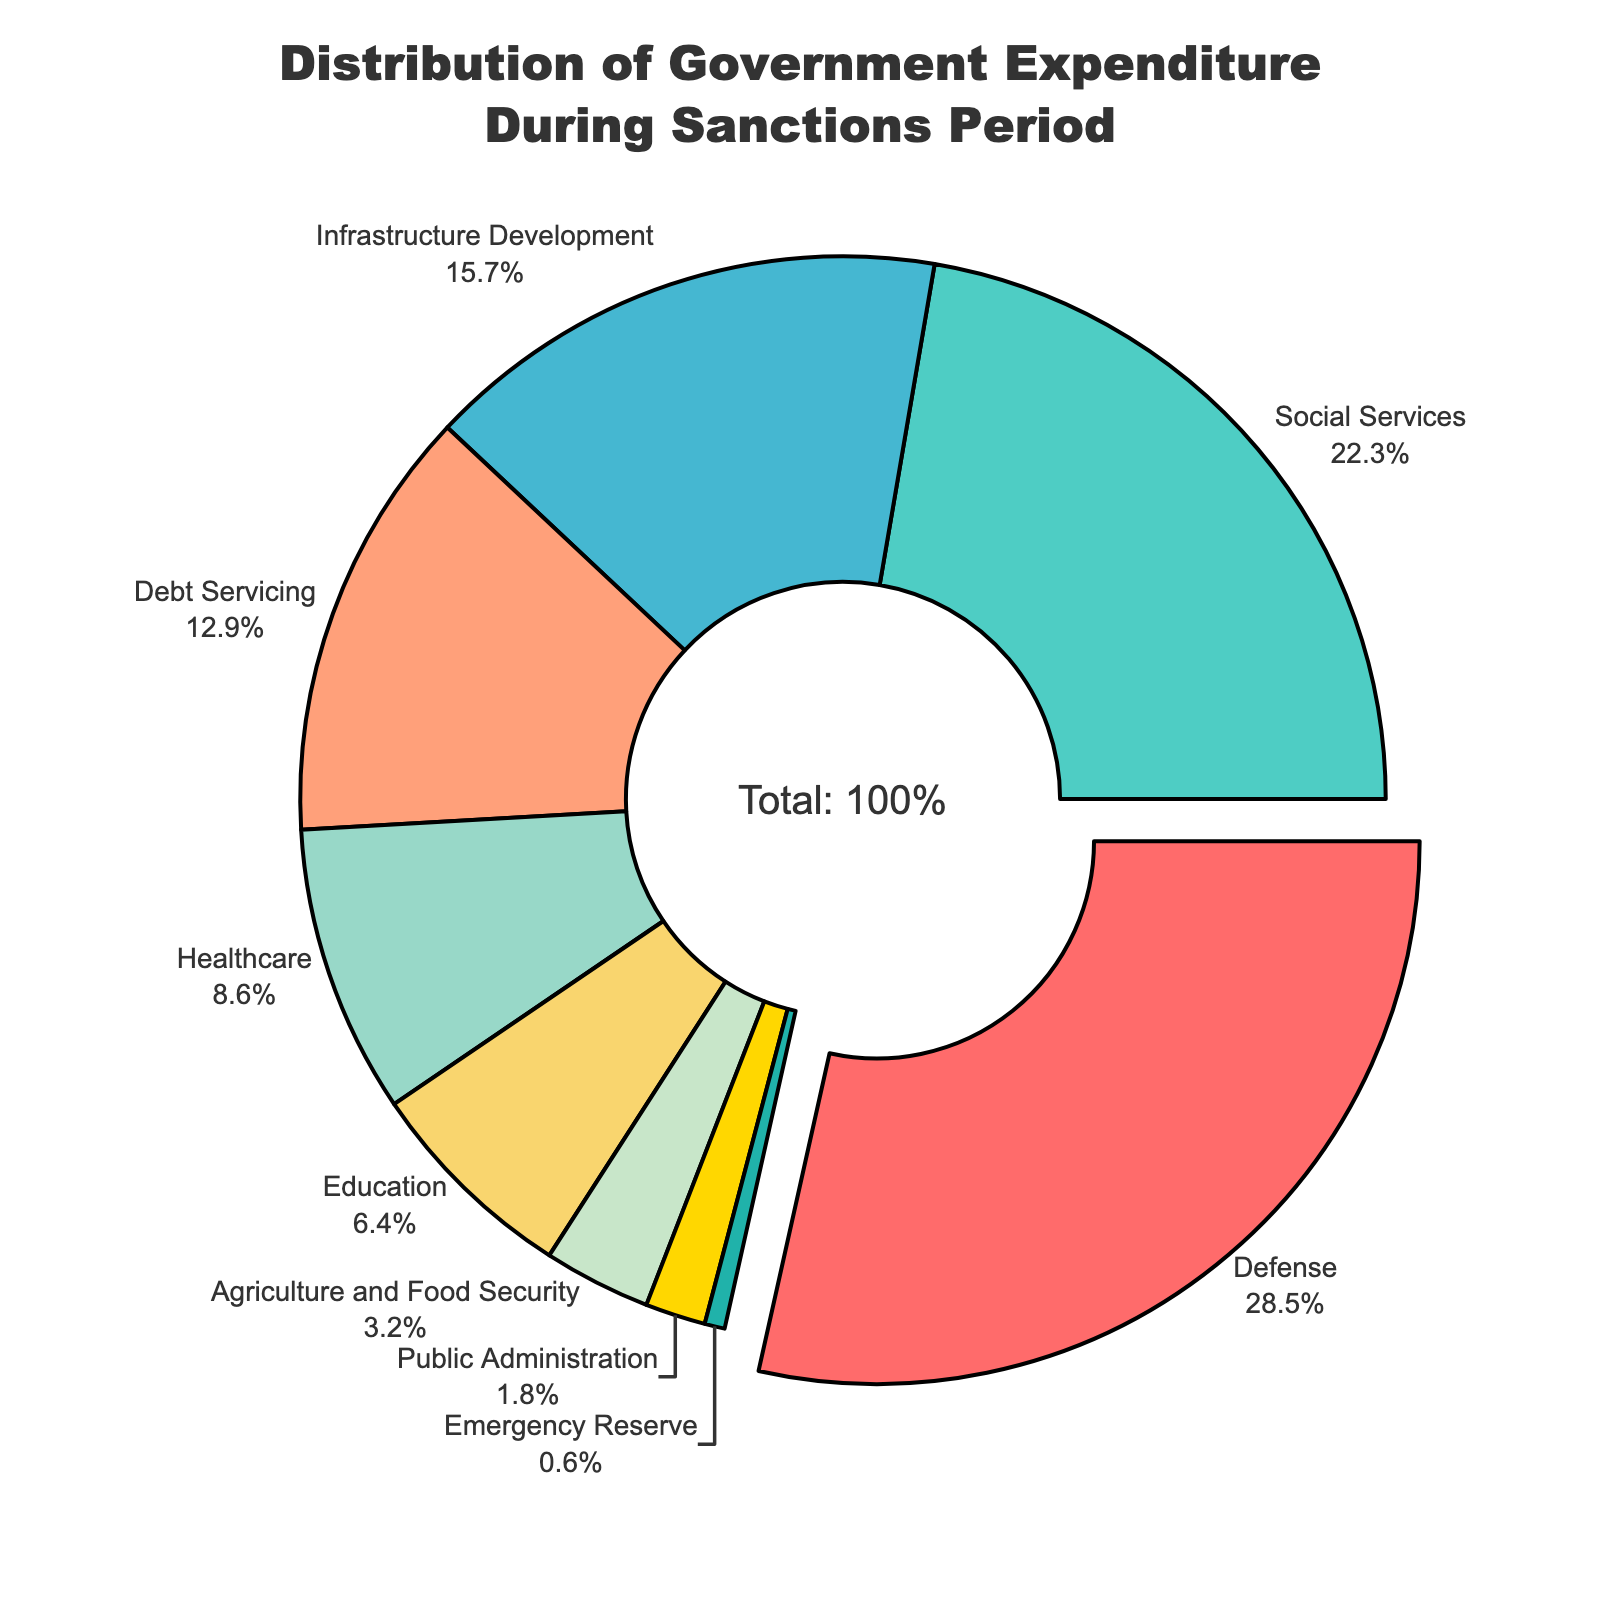what percentage of the government expenditure is allocated to Defense and Healthcare combined? To get the combined percentage, sum the percentages allocated to Defense (28.5%) and Healthcare (8.6%). Hence, 28.5 + 8.6 = 37.1%.
Answer: 37.1% Which category received the second largest allocation of government expenditure? The figure shows that Defense has the largest percentage (28.5%). The second largest percentage is for Social Services at 22.3%.
Answer: Social Services What is the difference in percentage between Infrastructure Development and Agriculture and Food Security? Subtract the percentage of Agriculture and Food Security (3.2%) from Infrastructure Development (15.7%). Hence, 15.7 - 3.2 = 12.5%.
Answer: 12.5% By how much does the Debt Servicing percentage exceed the Education percentage? Subtract the Education percentage (6.4%) from Debt Servicing (12.9%). Hence, 12.9 - 6.4 = 6.5%.
Answer: 6.5% Which category occupies the smallest section of the chart, and what is its percentage? The figure shows that Emergency Reserve has the smallest section with a percentage of 0.6%.
Answer: Emergency Reserve, 0.6% How does the percentage of Public Administration compare to Emergency Reserve? The figure shows Public Administration has a percentage of 1.8%, which is greater than Emergency Reserve's 0.6%.
Answer: Greater Identify the category represented by the color represented by #FFA07A in the figure and its percentage. The color #FFA07A represents the Debt Servicing category, which has a percentage of 12.9%.
Answer: Debt Servicing, 12.9% If the total government expenditure is $1 billion, how much money is allocated to Social Services and Healthcare combined? The combined percentage for Social Services (22.3%) and Healthcare (8.6%) is 30.9%. Thus 30.9% of $1 billion is $309 million.
Answer: $309 million What percentage of the government expenditure is allocated to categories other than Defense, Social Services, and Infrastructure Development? First sum the percentages for Defense (28.5%), Social Services (22.3%), and Infrastructure Development (15.7%), which equals 66.5%. Then subtract from 100% to get the remainder: 100 - 66.5 = 33.5%.
Answer: 33.5% Which category has the largest "pulled" (exploded) section, and why is that significant? The largest "pulled" section is Defense with a percentage of 28.5%. The pull effect emphasizes that this category has the highest allocation.
Answer: Defense 